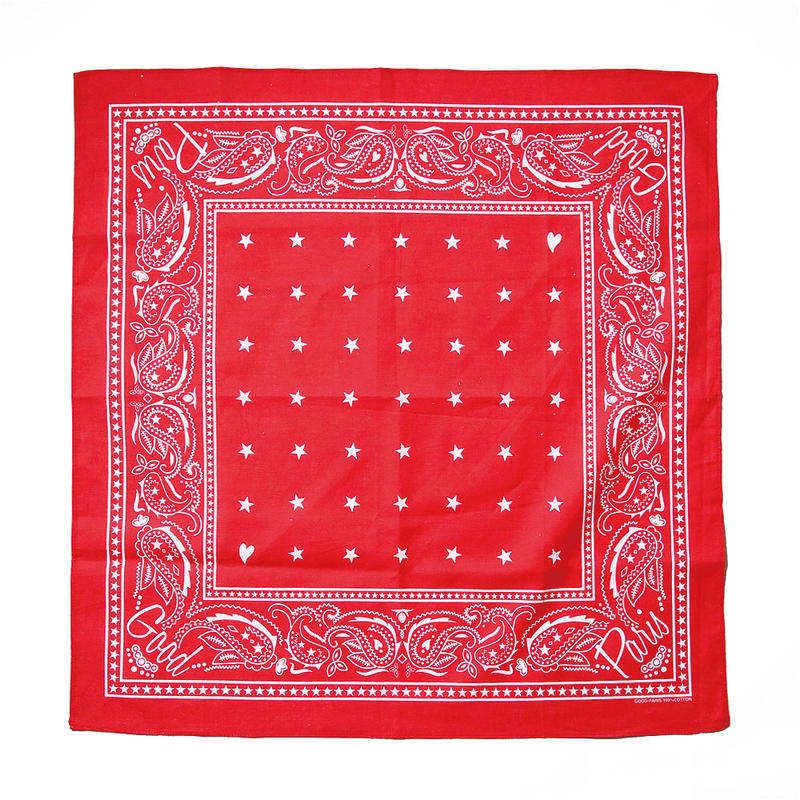What is the color scheme of the bandana, and how does it impact its overall visual appeal? The bandana features a vibrant red base with intricate white patterns. This classic red and white color scheme creates a striking contrast that visually pops, drawing attention to the detailed designs. Red often signifies energy and passion, while white accents add clarity and purity, making the bandana visually appealing and dynamic. How would you style this bandana in a modern outfit? Styling this bandana in a modern outfit can be quite versatile. For a casual look, fold the bandana into a triangle and tie it around your neck as a chic scarf paired with a white T-shirt and denim jacket. Alternatively, you can fold it into a thin strip and use it as a headband to add a pop of color to a minimalist ensemble. The bold red and white pattern would also serve as an excellent accent piece when tied to the handle of a black leather bag, giving an otherwise simple outfit a touch of character and flair. Imagine if this bandana had magical properties. What kind of powers would it possess? In a realm where fashion meets magic, this bandana holds the power to transform and animate. The intricate paisleys morph into protective spirits that shield the wearer from harm, while the stars glow with a guiding light, illuminating the path in times of uncertainty. Should the wearer need to conceal themselves, the bandana can blend with the surroundings, rendering them invisible. Worn with intention, it has the ability to project the wearer’s thoughts and feelings into vivid illusions, making their dreams and desires nearly tangible. 